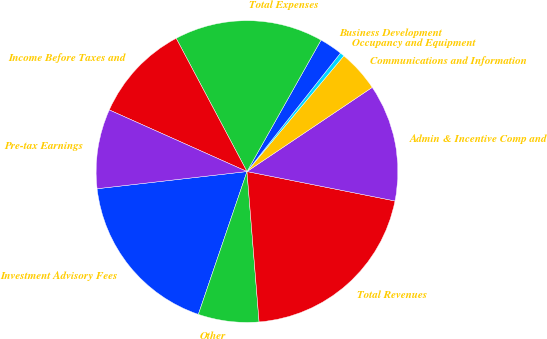Convert chart to OTSL. <chart><loc_0><loc_0><loc_500><loc_500><pie_chart><fcel>Investment Advisory Fees<fcel>Other<fcel>Total Revenues<fcel>Admin & Incentive Comp and<fcel>Communications and Information<fcel>Occupancy and Equipment<fcel>Business Development<fcel>Total Expenses<fcel>Income Before Taxes and<fcel>Pre-tax Earnings<nl><fcel>17.96%<fcel>6.5%<fcel>20.6%<fcel>12.54%<fcel>4.49%<fcel>0.46%<fcel>2.47%<fcel>15.94%<fcel>10.53%<fcel>8.51%<nl></chart> 